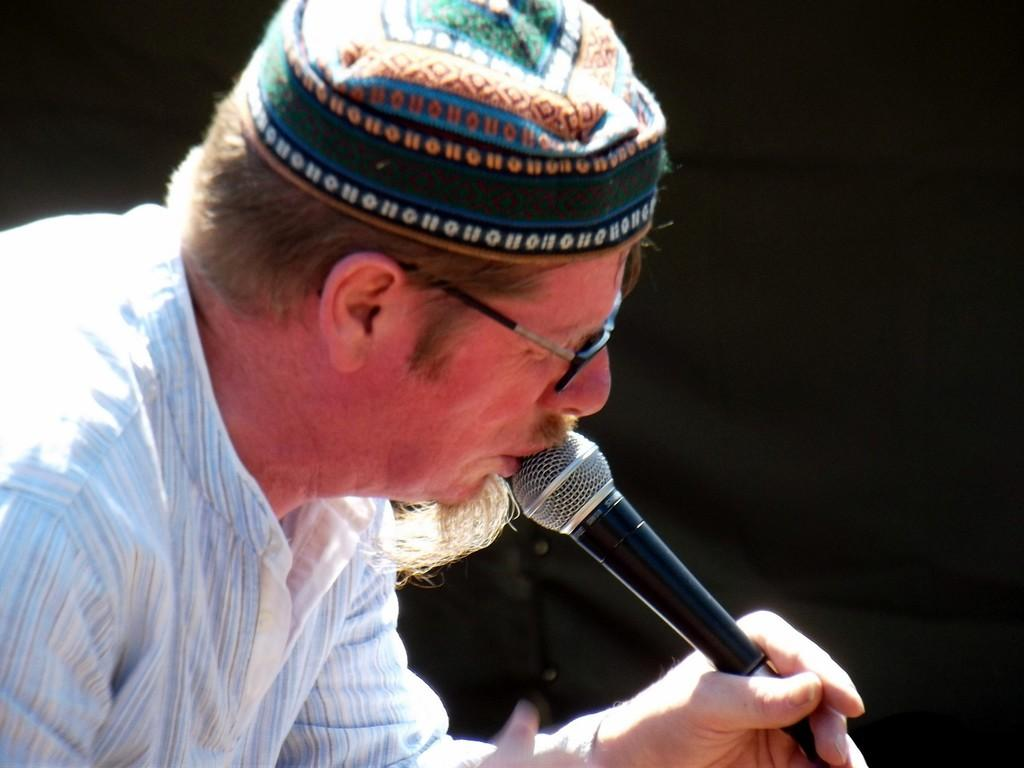Who is present in the image? There is a man in the image. What accessories is the man wearing? The man is wearing glasses (specs) and a hat. What is the man holding in the image? The man is holding a black color microphone. What is the color of the background in the image? The background of the image is black. What is the man's opinion on the road in the image? There is no road present in the image, and therefore no context for the man's opinion on it. 